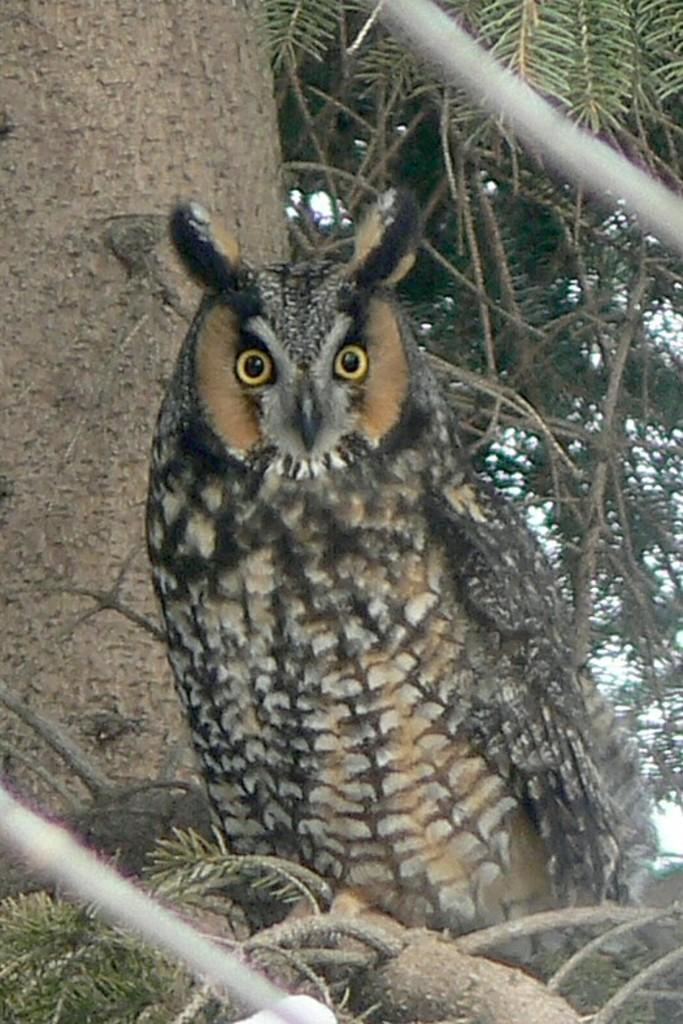What animal is present in the image? There is an owl in the image. Where is the owl located? The owl is on the branch of a tree. What can be seen in the background of the image? There are leaves visible in the background of the image. How many balloons are tied to the owl's feet in the image? There are no balloons present in the image; it features an owl on a tree branch. What type of bells can be heard ringing in the image? There are no bells present in the image, and therefore no sounds can be heard. 